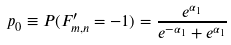Convert formula to latex. <formula><loc_0><loc_0><loc_500><loc_500>p _ { 0 } \equiv P ( F _ { m , n } ^ { \prime } = - 1 ) = \frac { e ^ { \alpha _ { 1 } } } { e ^ { - \alpha _ { 1 } } + e ^ { \alpha _ { 1 } } }</formula> 